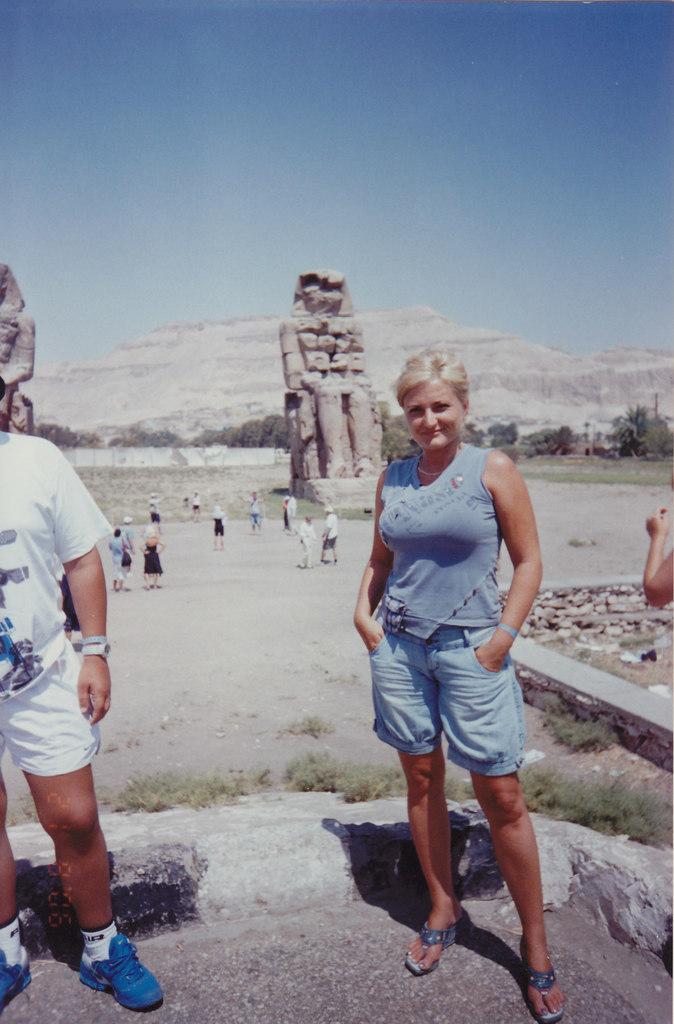Please provide a concise description of this image. In this image we can see a woman is standing on the ground, at beside here a man is standing, here is the grass, here are the group of people standing, at above here is the sky. 